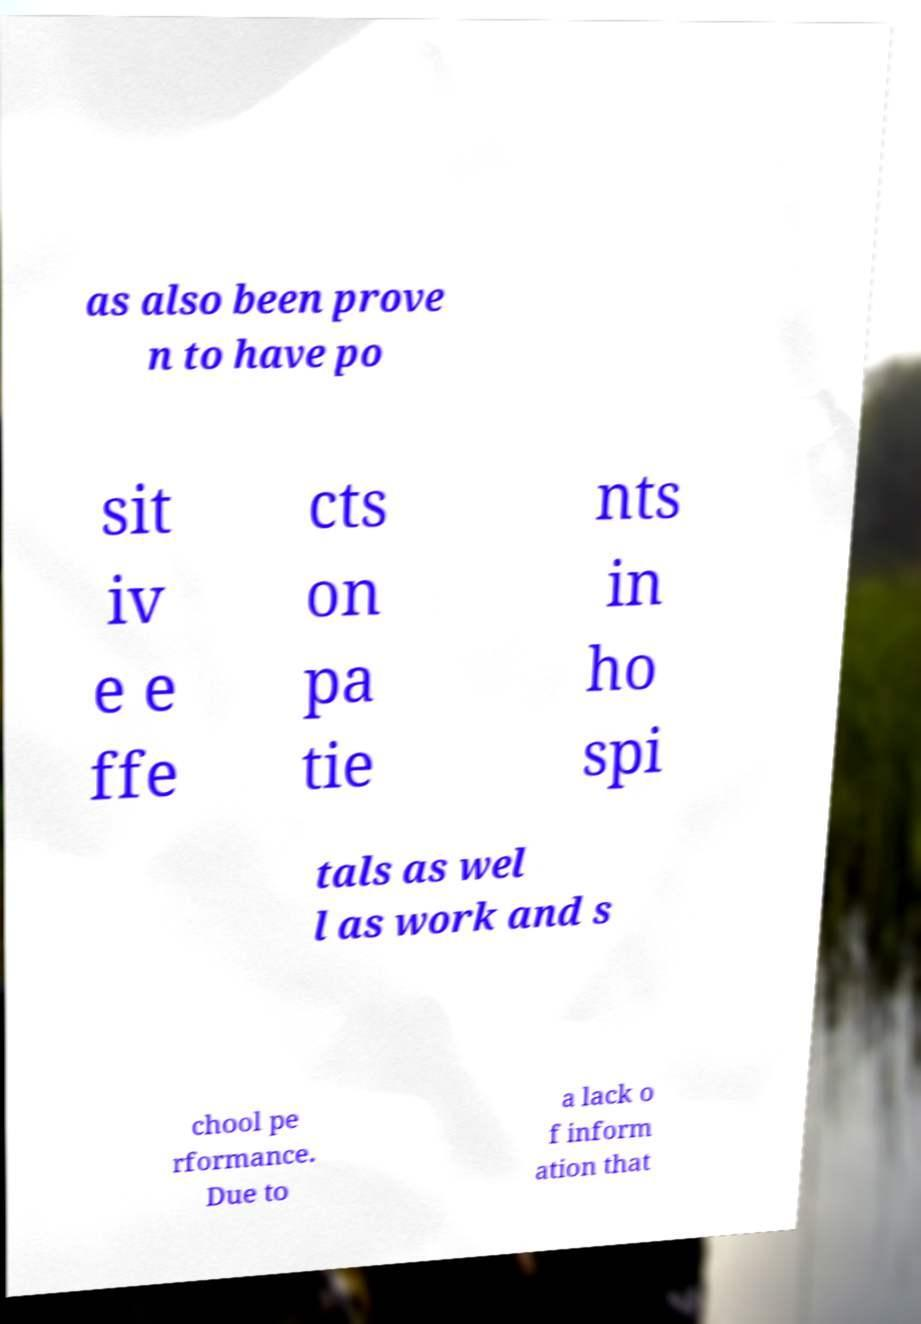Could you extract and type out the text from this image? as also been prove n to have po sit iv e e ffe cts on pa tie nts in ho spi tals as wel l as work and s chool pe rformance. Due to a lack o f inform ation that 